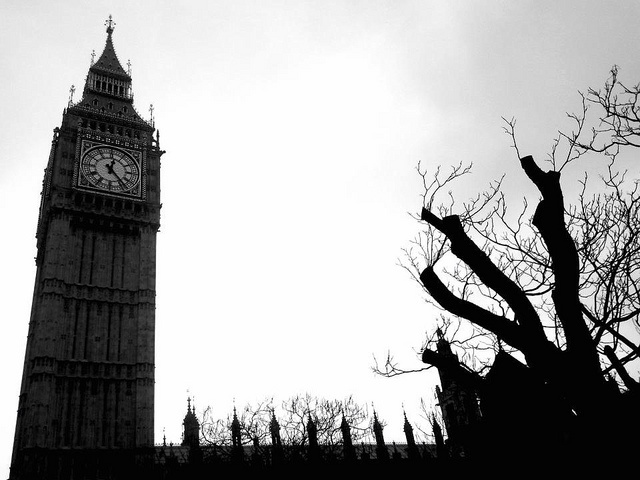Describe the objects in this image and their specific colors. I can see a clock in black, gray, and lightgray tones in this image. 